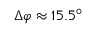<formula> <loc_0><loc_0><loc_500><loc_500>\Delta \varphi \approx 1 5 . 5 ^ { \circ }</formula> 